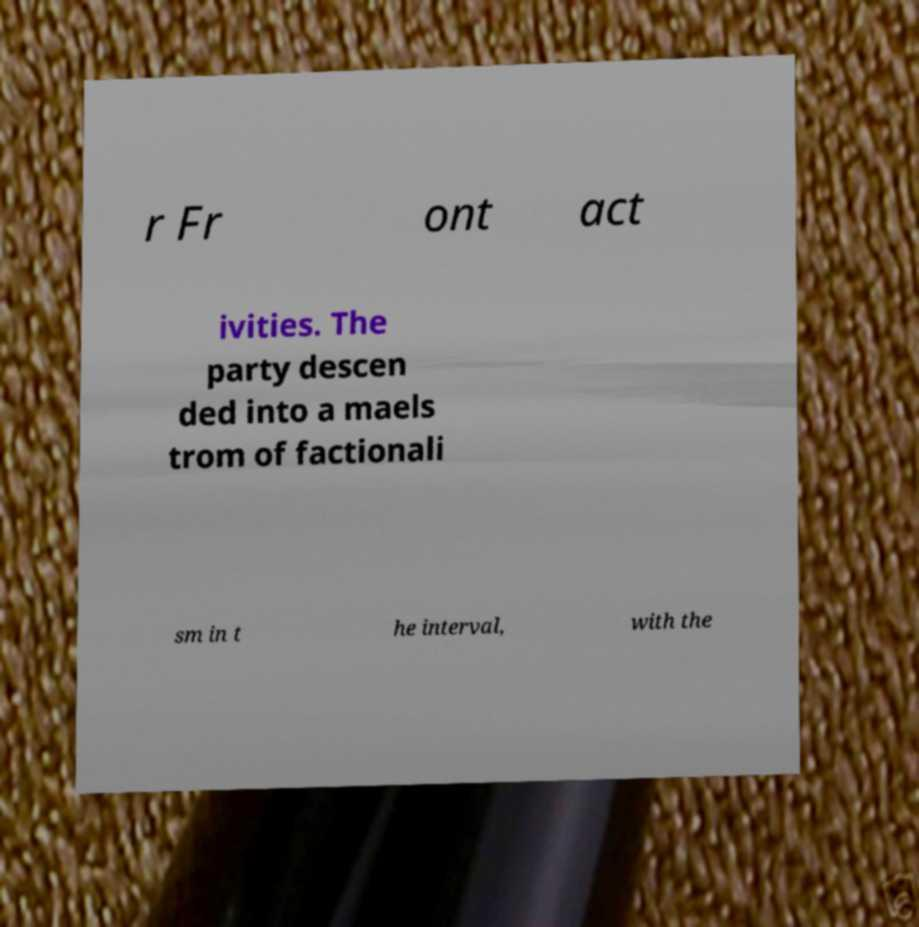There's text embedded in this image that I need extracted. Can you transcribe it verbatim? r Fr ont act ivities. The party descen ded into a maels trom of factionali sm in t he interval, with the 